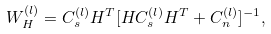<formula> <loc_0><loc_0><loc_500><loc_500>W _ { H } ^ { ( l ) } = C _ { s } ^ { ( l ) } H ^ { T } [ H C _ { s } ^ { ( l ) } H ^ { T } + C _ { n } ^ { ( l ) } ] ^ { - 1 } ,</formula> 